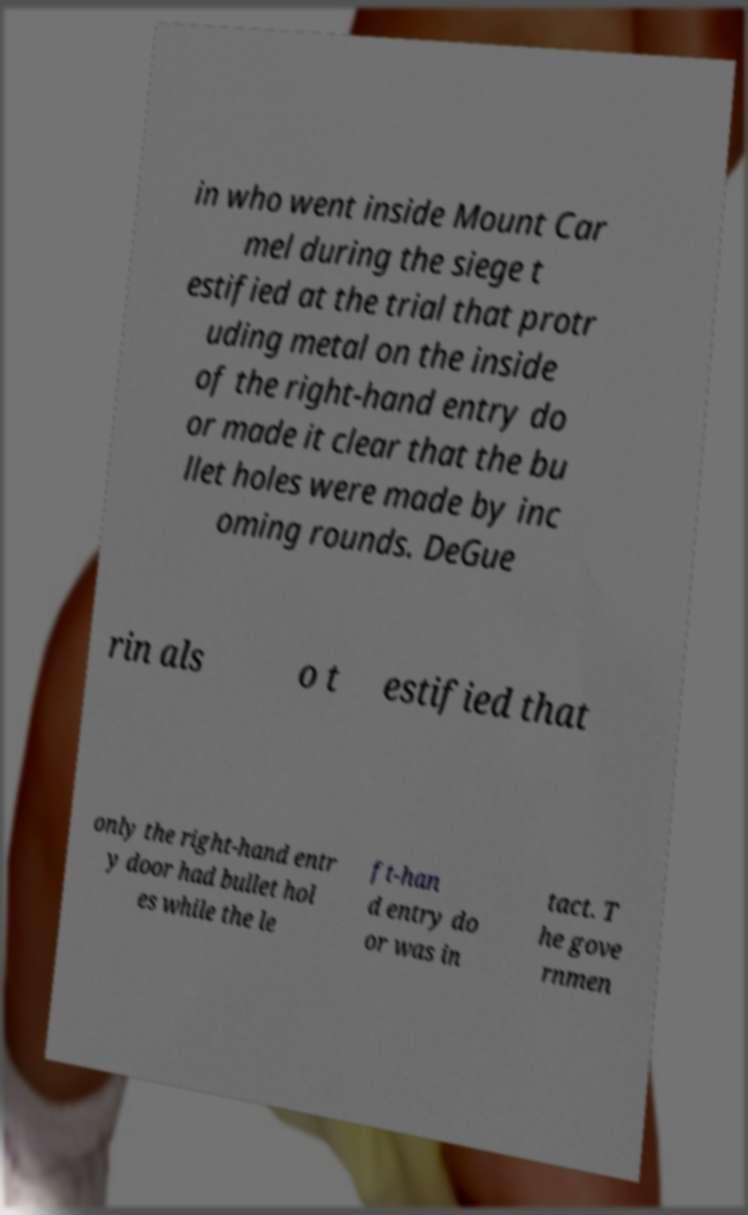There's text embedded in this image that I need extracted. Can you transcribe it verbatim? in who went inside Mount Car mel during the siege t estified at the trial that protr uding metal on the inside of the right-hand entry do or made it clear that the bu llet holes were made by inc oming rounds. DeGue rin als o t estified that only the right-hand entr y door had bullet hol es while the le ft-han d entry do or was in tact. T he gove rnmen 